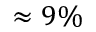<formula> <loc_0><loc_0><loc_500><loc_500>\approx 9 \%</formula> 